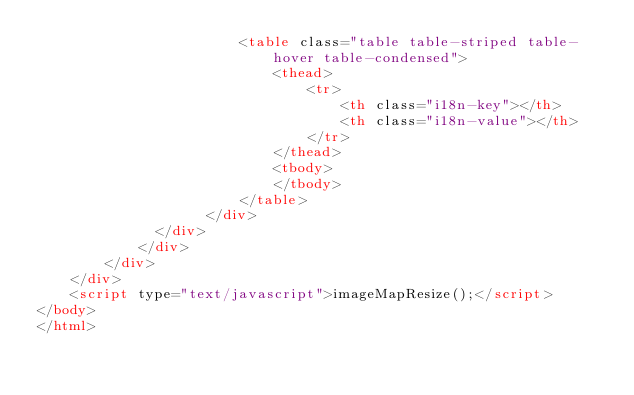Convert code to text. <code><loc_0><loc_0><loc_500><loc_500><_HTML_>						<table class="table table-striped table-hover table-condensed">
							<thead>
								<tr>
									<th class="i18n-key"></th>
									<th class="i18n-value"></th>
								</tr>
							</thead>
							<tbody>
							</tbody>
						</table>
					</div>
			  </div>
			</div>
		</div>
	</div>
	<script type="text/javascript">imageMapResize();</script>
</body>
</html></code> 